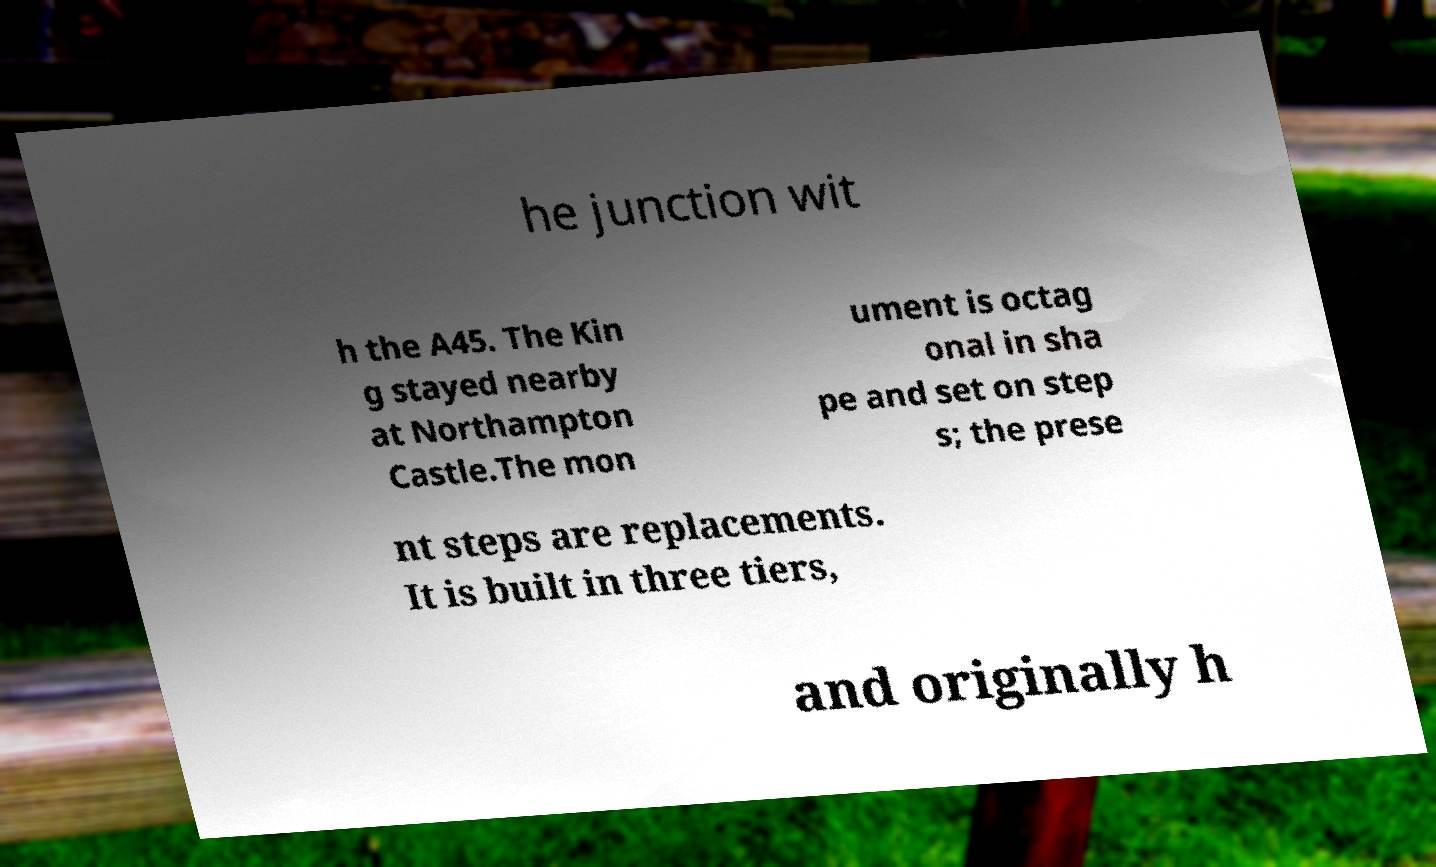Can you accurately transcribe the text from the provided image for me? he junction wit h the A45. The Kin g stayed nearby at Northampton Castle.The mon ument is octag onal in sha pe and set on step s; the prese nt steps are replacements. It is built in three tiers, and originally h 